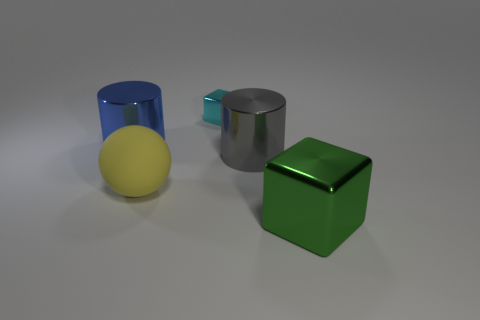What number of blue cylinders have the same size as the yellow matte thing?
Your answer should be very brief. 1. What number of things are large yellow matte spheres or objects that are in front of the blue metallic cylinder?
Keep it short and to the point. 3. What color is the thing that is on the left side of the small cyan thing and to the right of the blue metal cylinder?
Your response must be concise. Yellow. Do the matte sphere and the gray metallic thing have the same size?
Provide a short and direct response. Yes. There is a metal block left of the large shiny cube; what is its color?
Provide a short and direct response. Cyan. Is there a big rubber thing that has the same color as the tiny block?
Provide a succinct answer. No. What color is the matte ball that is the same size as the green metallic block?
Provide a short and direct response. Yellow. Is the large matte object the same shape as the blue thing?
Provide a short and direct response. No. What is the cube behind the blue object made of?
Offer a very short reply. Metal. The rubber object is what color?
Provide a succinct answer. Yellow. 